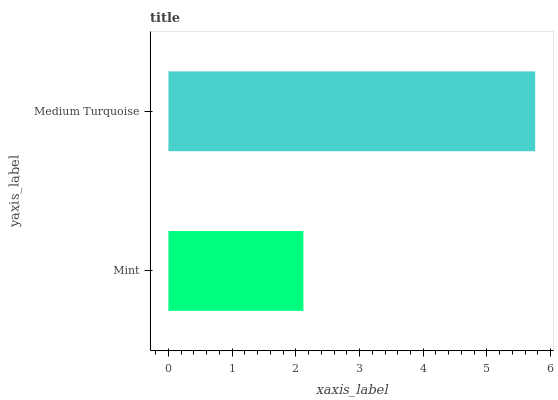Is Mint the minimum?
Answer yes or no. Yes. Is Medium Turquoise the maximum?
Answer yes or no. Yes. Is Medium Turquoise the minimum?
Answer yes or no. No. Is Medium Turquoise greater than Mint?
Answer yes or no. Yes. Is Mint less than Medium Turquoise?
Answer yes or no. Yes. Is Mint greater than Medium Turquoise?
Answer yes or no. No. Is Medium Turquoise less than Mint?
Answer yes or no. No. Is Medium Turquoise the high median?
Answer yes or no. Yes. Is Mint the low median?
Answer yes or no. Yes. Is Mint the high median?
Answer yes or no. No. Is Medium Turquoise the low median?
Answer yes or no. No. 